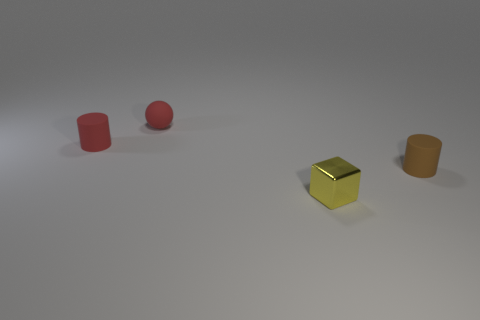Subtract all brown cylinders. How many cylinders are left? 1 Add 4 small cyan metal things. How many objects exist? 8 Subtract 1 brown cylinders. How many objects are left? 3 Subtract all brown balls. Subtract all purple blocks. How many balls are left? 1 Subtract all purple balls. How many brown cylinders are left? 1 Subtract all tiny brown things. Subtract all tiny red metal cylinders. How many objects are left? 3 Add 3 red balls. How many red balls are left? 4 Add 4 red cylinders. How many red cylinders exist? 5 